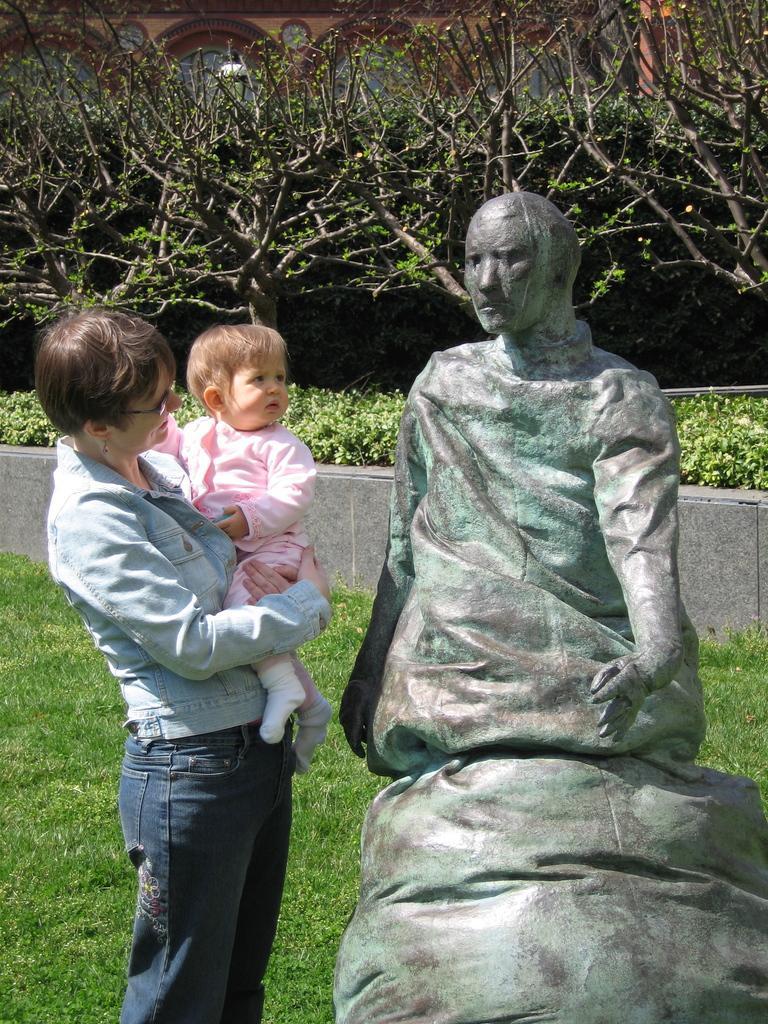Please provide a concise description of this image. In this picture I can observe woman and baby on the left side. On the right side I can observe a statue. There is some grass on the ground. In the background there are trees. 